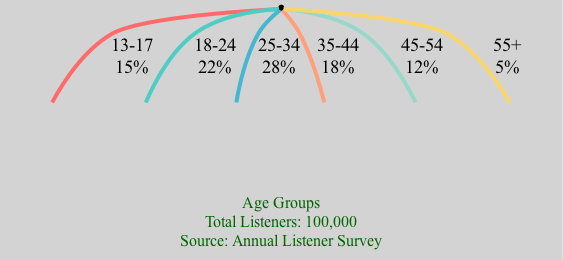What is the percentage of listeners aged 18-24? The pie chart indicates that the segment representing listeners aged 18-24 has a percentage of 22. This information can be found by locating the specific segment labeled "18-24" within the chart.
Answer: 22 What age group has the smallest percentage of listeners? By comparing the percentages of all age groups in the chart, the age group "55+" has the smallest percentage at 5. This is determined by identifying all segments and noting the lowest value.
Answer: 5 How many age groups are represented in the diagram? The diagram includes six distinct age groups. This can be determined by counting the number of segments shown in the pie chart.
Answer: 6 What percentage of listeners fall in the age group 35-44? The age group "35-44" is indicated to have a percentage of 18 in the pie chart. This is found by looking for the corresponding segment in the chart.
Answer: 18 Which age group represents the largest segment of listeners? The largest segment is for the age group "25-34," which accounts for 28% of the listeners. This can be identified by examining the percentages of all the segments and finding the highest value.
Answer: 28 What is the total number of listeners represented in the diagram? The total number of listeners represented is 100,000, which is explicitly stated in the diagram's legend.
Answer: 100,000 What percentage of listeners are aged 45-54? The chart shows that the percentage of listeners aged 45-54 is 12. This is found by locating the segment labeled "45-54" and noting the corresponding percentage.
Answer: 12 How does the percentage of listeners aged 13-17 compare to those aged 55+? The percentage of listeners aged 13-17 is 15, while those aged 55+ is 5. Thus, listeners aged 13-17 represent a higher percentage than those aged 55+, which can be seen by comparing the two segments directly.
Answer: Higher What does the legend specify about the data source? The legend specifies that the data source is the "Annual Listener Survey." This information is included in the description at the bottom of the chart.
Answer: Annual Listener Survey What is the combined percentage of listeners in the age groups 18-24 and 35-44? Adding the percentages of the age groups 18-24 (22) and 35-44 (18) gives a combined total of 40. This involves summing the two specific values presented in the chart.
Answer: 40 